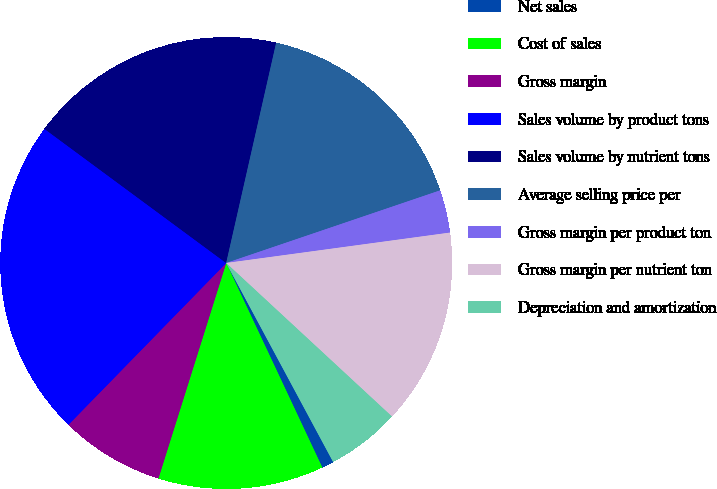<chart> <loc_0><loc_0><loc_500><loc_500><pie_chart><fcel>Net sales<fcel>Cost of sales<fcel>Gross margin<fcel>Sales volume by product tons<fcel>Sales volume by nutrient tons<fcel>Average selling price per<fcel>Gross margin per product ton<fcel>Gross margin per nutrient ton<fcel>Depreciation and amortization<nl><fcel>0.86%<fcel>11.84%<fcel>7.45%<fcel>22.82%<fcel>18.43%<fcel>16.24%<fcel>3.06%<fcel>14.04%<fcel>5.26%<nl></chart> 